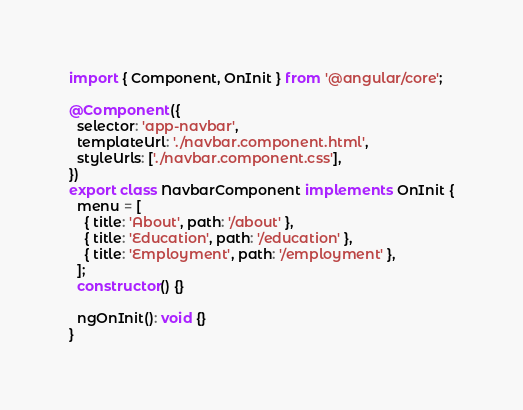Convert code to text. <code><loc_0><loc_0><loc_500><loc_500><_TypeScript_>import { Component, OnInit } from '@angular/core';

@Component({
  selector: 'app-navbar',
  templateUrl: './navbar.component.html',
  styleUrls: ['./navbar.component.css'],
})
export class NavbarComponent implements OnInit {
  menu = [
    { title: 'About', path: '/about' },
    { title: 'Education', path: '/education' },
    { title: 'Employment', path: '/employment' },
  ];
  constructor() {}

  ngOnInit(): void {}
}
</code> 